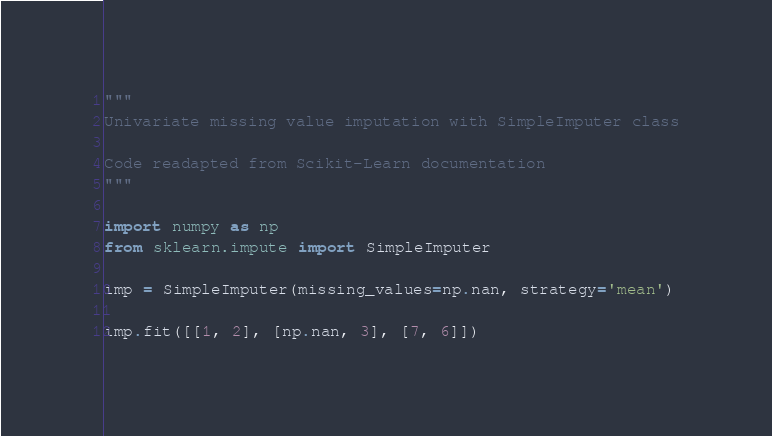Convert code to text. <code><loc_0><loc_0><loc_500><loc_500><_Python_>"""
Univariate missing value imputation with SimpleImputer class

Code readapted from Scikit-Learn documentation
"""

import numpy as np
from sklearn.impute import SimpleImputer

imp = SimpleImputer(missing_values=np.nan, strategy='mean')

imp.fit([[1, 2], [np.nan, 3], [7, 6]])
</code> 